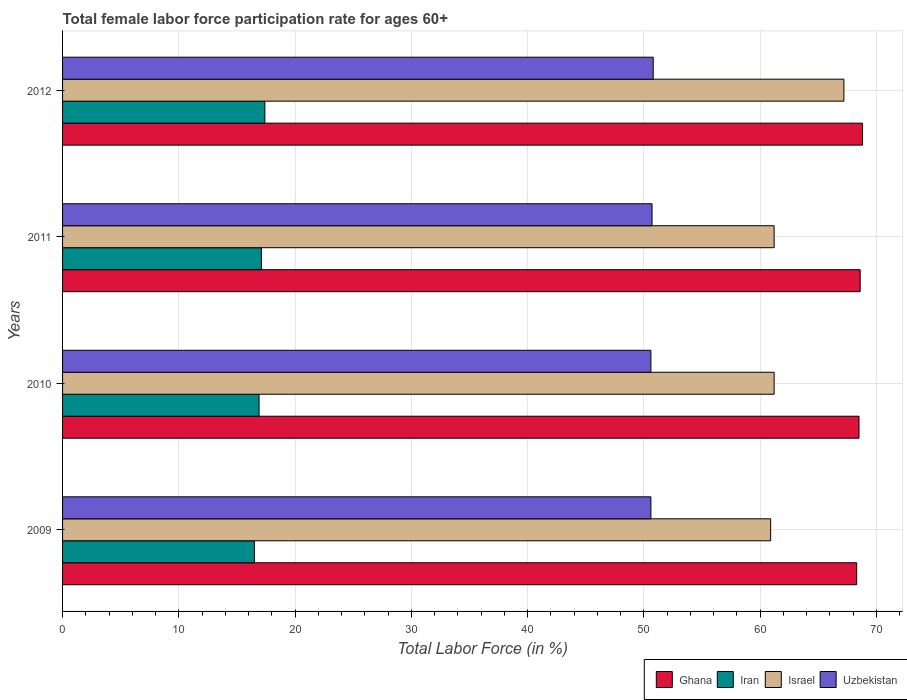How many different coloured bars are there?
Offer a very short reply. 4. How many groups of bars are there?
Make the answer very short. 4. Are the number of bars per tick equal to the number of legend labels?
Provide a short and direct response. Yes. Are the number of bars on each tick of the Y-axis equal?
Provide a short and direct response. Yes. How many bars are there on the 4th tick from the bottom?
Keep it short and to the point. 4. What is the label of the 3rd group of bars from the top?
Your answer should be compact. 2010. What is the female labor force participation rate in Uzbekistan in 2012?
Your answer should be compact. 50.8. Across all years, what is the maximum female labor force participation rate in Israel?
Provide a succinct answer. 67.2. Across all years, what is the minimum female labor force participation rate in Uzbekistan?
Make the answer very short. 50.6. What is the total female labor force participation rate in Israel in the graph?
Ensure brevity in your answer.  250.5. What is the difference between the female labor force participation rate in Uzbekistan in 2010 and that in 2012?
Your answer should be very brief. -0.2. What is the difference between the female labor force participation rate in Uzbekistan in 2009 and the female labor force participation rate in Ghana in 2011?
Your response must be concise. -18. What is the average female labor force participation rate in Ghana per year?
Ensure brevity in your answer.  68.55. In the year 2011, what is the difference between the female labor force participation rate in Iran and female labor force participation rate in Ghana?
Your answer should be very brief. -51.5. What is the ratio of the female labor force participation rate in Uzbekistan in 2010 to that in 2012?
Make the answer very short. 1. Is the female labor force participation rate in Uzbekistan in 2010 less than that in 2011?
Give a very brief answer. Yes. What is the difference between the highest and the second highest female labor force participation rate in Israel?
Ensure brevity in your answer.  6. What is the difference between the highest and the lowest female labor force participation rate in Israel?
Provide a short and direct response. 6.3. Is the sum of the female labor force participation rate in Iran in 2010 and 2011 greater than the maximum female labor force participation rate in Ghana across all years?
Provide a succinct answer. No. Is it the case that in every year, the sum of the female labor force participation rate in Uzbekistan and female labor force participation rate in Iran is greater than the sum of female labor force participation rate in Ghana and female labor force participation rate in Israel?
Offer a very short reply. No. What does the 3rd bar from the top in 2010 represents?
Provide a short and direct response. Iran. How many years are there in the graph?
Give a very brief answer. 4. What is the difference between two consecutive major ticks on the X-axis?
Ensure brevity in your answer.  10. Are the values on the major ticks of X-axis written in scientific E-notation?
Make the answer very short. No. Does the graph contain any zero values?
Your answer should be very brief. No. How are the legend labels stacked?
Provide a succinct answer. Horizontal. What is the title of the graph?
Your answer should be compact. Total female labor force participation rate for ages 60+. What is the label or title of the X-axis?
Provide a short and direct response. Total Labor Force (in %). What is the Total Labor Force (in %) of Ghana in 2009?
Your answer should be compact. 68.3. What is the Total Labor Force (in %) in Iran in 2009?
Your answer should be very brief. 16.5. What is the Total Labor Force (in %) in Israel in 2009?
Keep it short and to the point. 60.9. What is the Total Labor Force (in %) in Uzbekistan in 2009?
Your answer should be very brief. 50.6. What is the Total Labor Force (in %) of Ghana in 2010?
Provide a succinct answer. 68.5. What is the Total Labor Force (in %) in Iran in 2010?
Provide a succinct answer. 16.9. What is the Total Labor Force (in %) in Israel in 2010?
Offer a terse response. 61.2. What is the Total Labor Force (in %) in Uzbekistan in 2010?
Ensure brevity in your answer.  50.6. What is the Total Labor Force (in %) of Ghana in 2011?
Give a very brief answer. 68.6. What is the Total Labor Force (in %) of Iran in 2011?
Offer a very short reply. 17.1. What is the Total Labor Force (in %) in Israel in 2011?
Provide a succinct answer. 61.2. What is the Total Labor Force (in %) in Uzbekistan in 2011?
Offer a terse response. 50.7. What is the Total Labor Force (in %) of Ghana in 2012?
Make the answer very short. 68.8. What is the Total Labor Force (in %) of Iran in 2012?
Make the answer very short. 17.4. What is the Total Labor Force (in %) of Israel in 2012?
Ensure brevity in your answer.  67.2. What is the Total Labor Force (in %) of Uzbekistan in 2012?
Offer a terse response. 50.8. Across all years, what is the maximum Total Labor Force (in %) in Ghana?
Ensure brevity in your answer.  68.8. Across all years, what is the maximum Total Labor Force (in %) in Iran?
Provide a short and direct response. 17.4. Across all years, what is the maximum Total Labor Force (in %) of Israel?
Your answer should be very brief. 67.2. Across all years, what is the maximum Total Labor Force (in %) of Uzbekistan?
Your answer should be compact. 50.8. Across all years, what is the minimum Total Labor Force (in %) in Ghana?
Make the answer very short. 68.3. Across all years, what is the minimum Total Labor Force (in %) of Iran?
Keep it short and to the point. 16.5. Across all years, what is the minimum Total Labor Force (in %) in Israel?
Keep it short and to the point. 60.9. Across all years, what is the minimum Total Labor Force (in %) in Uzbekistan?
Offer a very short reply. 50.6. What is the total Total Labor Force (in %) in Ghana in the graph?
Provide a short and direct response. 274.2. What is the total Total Labor Force (in %) of Iran in the graph?
Offer a terse response. 67.9. What is the total Total Labor Force (in %) in Israel in the graph?
Provide a short and direct response. 250.5. What is the total Total Labor Force (in %) in Uzbekistan in the graph?
Offer a terse response. 202.7. What is the difference between the Total Labor Force (in %) of Ghana in 2009 and that in 2010?
Make the answer very short. -0.2. What is the difference between the Total Labor Force (in %) in Iran in 2009 and that in 2010?
Provide a short and direct response. -0.4. What is the difference between the Total Labor Force (in %) of Ghana in 2009 and that in 2011?
Your answer should be very brief. -0.3. What is the difference between the Total Labor Force (in %) in Uzbekistan in 2009 and that in 2011?
Your response must be concise. -0.1. What is the difference between the Total Labor Force (in %) of Ghana in 2009 and that in 2012?
Your response must be concise. -0.5. What is the difference between the Total Labor Force (in %) of Iran in 2009 and that in 2012?
Provide a short and direct response. -0.9. What is the difference between the Total Labor Force (in %) of Ghana in 2010 and that in 2011?
Offer a terse response. -0.1. What is the difference between the Total Labor Force (in %) in Iran in 2010 and that in 2011?
Provide a succinct answer. -0.2. What is the difference between the Total Labor Force (in %) of Israel in 2010 and that in 2011?
Your answer should be very brief. 0. What is the difference between the Total Labor Force (in %) of Uzbekistan in 2010 and that in 2011?
Your answer should be very brief. -0.1. What is the difference between the Total Labor Force (in %) in Iran in 2010 and that in 2012?
Give a very brief answer. -0.5. What is the difference between the Total Labor Force (in %) in Israel in 2010 and that in 2012?
Offer a terse response. -6. What is the difference between the Total Labor Force (in %) in Ghana in 2011 and that in 2012?
Offer a terse response. -0.2. What is the difference between the Total Labor Force (in %) of Iran in 2011 and that in 2012?
Provide a short and direct response. -0.3. What is the difference between the Total Labor Force (in %) of Israel in 2011 and that in 2012?
Your response must be concise. -6. What is the difference between the Total Labor Force (in %) of Ghana in 2009 and the Total Labor Force (in %) of Iran in 2010?
Give a very brief answer. 51.4. What is the difference between the Total Labor Force (in %) in Iran in 2009 and the Total Labor Force (in %) in Israel in 2010?
Give a very brief answer. -44.7. What is the difference between the Total Labor Force (in %) of Iran in 2009 and the Total Labor Force (in %) of Uzbekistan in 2010?
Keep it short and to the point. -34.1. What is the difference between the Total Labor Force (in %) in Israel in 2009 and the Total Labor Force (in %) in Uzbekistan in 2010?
Provide a succinct answer. 10.3. What is the difference between the Total Labor Force (in %) in Ghana in 2009 and the Total Labor Force (in %) in Iran in 2011?
Provide a short and direct response. 51.2. What is the difference between the Total Labor Force (in %) of Ghana in 2009 and the Total Labor Force (in %) of Uzbekistan in 2011?
Provide a short and direct response. 17.6. What is the difference between the Total Labor Force (in %) in Iran in 2009 and the Total Labor Force (in %) in Israel in 2011?
Offer a terse response. -44.7. What is the difference between the Total Labor Force (in %) of Iran in 2009 and the Total Labor Force (in %) of Uzbekistan in 2011?
Keep it short and to the point. -34.2. What is the difference between the Total Labor Force (in %) of Israel in 2009 and the Total Labor Force (in %) of Uzbekistan in 2011?
Keep it short and to the point. 10.2. What is the difference between the Total Labor Force (in %) of Ghana in 2009 and the Total Labor Force (in %) of Iran in 2012?
Provide a succinct answer. 50.9. What is the difference between the Total Labor Force (in %) in Ghana in 2009 and the Total Labor Force (in %) in Israel in 2012?
Keep it short and to the point. 1.1. What is the difference between the Total Labor Force (in %) of Iran in 2009 and the Total Labor Force (in %) of Israel in 2012?
Keep it short and to the point. -50.7. What is the difference between the Total Labor Force (in %) of Iran in 2009 and the Total Labor Force (in %) of Uzbekistan in 2012?
Offer a terse response. -34.3. What is the difference between the Total Labor Force (in %) of Israel in 2009 and the Total Labor Force (in %) of Uzbekistan in 2012?
Offer a very short reply. 10.1. What is the difference between the Total Labor Force (in %) in Ghana in 2010 and the Total Labor Force (in %) in Iran in 2011?
Offer a terse response. 51.4. What is the difference between the Total Labor Force (in %) in Ghana in 2010 and the Total Labor Force (in %) in Israel in 2011?
Your answer should be compact. 7.3. What is the difference between the Total Labor Force (in %) in Ghana in 2010 and the Total Labor Force (in %) in Uzbekistan in 2011?
Offer a terse response. 17.8. What is the difference between the Total Labor Force (in %) in Iran in 2010 and the Total Labor Force (in %) in Israel in 2011?
Give a very brief answer. -44.3. What is the difference between the Total Labor Force (in %) of Iran in 2010 and the Total Labor Force (in %) of Uzbekistan in 2011?
Provide a succinct answer. -33.8. What is the difference between the Total Labor Force (in %) of Israel in 2010 and the Total Labor Force (in %) of Uzbekistan in 2011?
Ensure brevity in your answer.  10.5. What is the difference between the Total Labor Force (in %) in Ghana in 2010 and the Total Labor Force (in %) in Iran in 2012?
Offer a terse response. 51.1. What is the difference between the Total Labor Force (in %) of Ghana in 2010 and the Total Labor Force (in %) of Israel in 2012?
Keep it short and to the point. 1.3. What is the difference between the Total Labor Force (in %) of Iran in 2010 and the Total Labor Force (in %) of Israel in 2012?
Keep it short and to the point. -50.3. What is the difference between the Total Labor Force (in %) in Iran in 2010 and the Total Labor Force (in %) in Uzbekistan in 2012?
Offer a terse response. -33.9. What is the difference between the Total Labor Force (in %) in Ghana in 2011 and the Total Labor Force (in %) in Iran in 2012?
Give a very brief answer. 51.2. What is the difference between the Total Labor Force (in %) in Ghana in 2011 and the Total Labor Force (in %) in Israel in 2012?
Provide a short and direct response. 1.4. What is the difference between the Total Labor Force (in %) of Ghana in 2011 and the Total Labor Force (in %) of Uzbekistan in 2012?
Keep it short and to the point. 17.8. What is the difference between the Total Labor Force (in %) in Iran in 2011 and the Total Labor Force (in %) in Israel in 2012?
Make the answer very short. -50.1. What is the difference between the Total Labor Force (in %) of Iran in 2011 and the Total Labor Force (in %) of Uzbekistan in 2012?
Your answer should be very brief. -33.7. What is the average Total Labor Force (in %) in Ghana per year?
Your response must be concise. 68.55. What is the average Total Labor Force (in %) in Iran per year?
Offer a very short reply. 16.98. What is the average Total Labor Force (in %) in Israel per year?
Offer a terse response. 62.62. What is the average Total Labor Force (in %) in Uzbekistan per year?
Your answer should be compact. 50.67. In the year 2009, what is the difference between the Total Labor Force (in %) of Ghana and Total Labor Force (in %) of Iran?
Ensure brevity in your answer.  51.8. In the year 2009, what is the difference between the Total Labor Force (in %) of Ghana and Total Labor Force (in %) of Uzbekistan?
Your response must be concise. 17.7. In the year 2009, what is the difference between the Total Labor Force (in %) in Iran and Total Labor Force (in %) in Israel?
Make the answer very short. -44.4. In the year 2009, what is the difference between the Total Labor Force (in %) in Iran and Total Labor Force (in %) in Uzbekistan?
Offer a terse response. -34.1. In the year 2009, what is the difference between the Total Labor Force (in %) of Israel and Total Labor Force (in %) of Uzbekistan?
Offer a terse response. 10.3. In the year 2010, what is the difference between the Total Labor Force (in %) of Ghana and Total Labor Force (in %) of Iran?
Your response must be concise. 51.6. In the year 2010, what is the difference between the Total Labor Force (in %) in Ghana and Total Labor Force (in %) in Israel?
Your response must be concise. 7.3. In the year 2010, what is the difference between the Total Labor Force (in %) of Iran and Total Labor Force (in %) of Israel?
Make the answer very short. -44.3. In the year 2010, what is the difference between the Total Labor Force (in %) in Iran and Total Labor Force (in %) in Uzbekistan?
Your response must be concise. -33.7. In the year 2011, what is the difference between the Total Labor Force (in %) of Ghana and Total Labor Force (in %) of Iran?
Your response must be concise. 51.5. In the year 2011, what is the difference between the Total Labor Force (in %) in Ghana and Total Labor Force (in %) in Israel?
Offer a very short reply. 7.4. In the year 2011, what is the difference between the Total Labor Force (in %) in Iran and Total Labor Force (in %) in Israel?
Ensure brevity in your answer.  -44.1. In the year 2011, what is the difference between the Total Labor Force (in %) in Iran and Total Labor Force (in %) in Uzbekistan?
Ensure brevity in your answer.  -33.6. In the year 2012, what is the difference between the Total Labor Force (in %) of Ghana and Total Labor Force (in %) of Iran?
Offer a very short reply. 51.4. In the year 2012, what is the difference between the Total Labor Force (in %) of Ghana and Total Labor Force (in %) of Uzbekistan?
Ensure brevity in your answer.  18. In the year 2012, what is the difference between the Total Labor Force (in %) in Iran and Total Labor Force (in %) in Israel?
Keep it short and to the point. -49.8. In the year 2012, what is the difference between the Total Labor Force (in %) in Iran and Total Labor Force (in %) in Uzbekistan?
Keep it short and to the point. -33.4. What is the ratio of the Total Labor Force (in %) in Iran in 2009 to that in 2010?
Give a very brief answer. 0.98. What is the ratio of the Total Labor Force (in %) of Israel in 2009 to that in 2010?
Keep it short and to the point. 1. What is the ratio of the Total Labor Force (in %) of Iran in 2009 to that in 2011?
Offer a very short reply. 0.96. What is the ratio of the Total Labor Force (in %) in Iran in 2009 to that in 2012?
Your response must be concise. 0.95. What is the ratio of the Total Labor Force (in %) of Israel in 2009 to that in 2012?
Offer a terse response. 0.91. What is the ratio of the Total Labor Force (in %) in Uzbekistan in 2009 to that in 2012?
Keep it short and to the point. 1. What is the ratio of the Total Labor Force (in %) in Ghana in 2010 to that in 2011?
Offer a terse response. 1. What is the ratio of the Total Labor Force (in %) of Iran in 2010 to that in 2011?
Your response must be concise. 0.99. What is the ratio of the Total Labor Force (in %) in Uzbekistan in 2010 to that in 2011?
Make the answer very short. 1. What is the ratio of the Total Labor Force (in %) in Ghana in 2010 to that in 2012?
Keep it short and to the point. 1. What is the ratio of the Total Labor Force (in %) of Iran in 2010 to that in 2012?
Ensure brevity in your answer.  0.97. What is the ratio of the Total Labor Force (in %) of Israel in 2010 to that in 2012?
Offer a very short reply. 0.91. What is the ratio of the Total Labor Force (in %) of Uzbekistan in 2010 to that in 2012?
Make the answer very short. 1. What is the ratio of the Total Labor Force (in %) of Iran in 2011 to that in 2012?
Make the answer very short. 0.98. What is the ratio of the Total Labor Force (in %) of Israel in 2011 to that in 2012?
Your response must be concise. 0.91. What is the difference between the highest and the second highest Total Labor Force (in %) of Ghana?
Keep it short and to the point. 0.2. What is the difference between the highest and the second highest Total Labor Force (in %) in Israel?
Provide a short and direct response. 6. What is the difference between the highest and the second highest Total Labor Force (in %) in Uzbekistan?
Ensure brevity in your answer.  0.1. What is the difference between the highest and the lowest Total Labor Force (in %) of Ghana?
Make the answer very short. 0.5. What is the difference between the highest and the lowest Total Labor Force (in %) of Uzbekistan?
Provide a succinct answer. 0.2. 